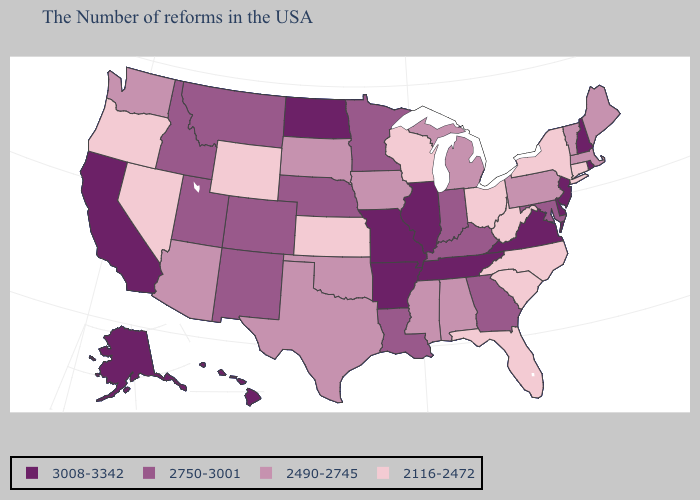Among the states that border Mississippi , does Alabama have the lowest value?
Quick response, please. Yes. Which states hav the highest value in the South?
Be succinct. Delaware, Virginia, Tennessee, Arkansas. What is the value of Connecticut?
Keep it brief. 2116-2472. Name the states that have a value in the range 2116-2472?
Keep it brief. Connecticut, New York, North Carolina, South Carolina, West Virginia, Ohio, Florida, Wisconsin, Kansas, Wyoming, Nevada, Oregon. Does the first symbol in the legend represent the smallest category?
Quick response, please. No. Name the states that have a value in the range 3008-3342?
Be succinct. Rhode Island, New Hampshire, New Jersey, Delaware, Virginia, Tennessee, Illinois, Missouri, Arkansas, North Dakota, California, Alaska, Hawaii. Does Maine have the highest value in the USA?
Quick response, please. No. What is the value of North Dakota?
Keep it brief. 3008-3342. Does Illinois have the highest value in the MidWest?
Short answer required. Yes. Name the states that have a value in the range 2490-2745?
Answer briefly. Maine, Massachusetts, Vermont, Pennsylvania, Michigan, Alabama, Mississippi, Iowa, Oklahoma, Texas, South Dakota, Arizona, Washington. What is the value of Washington?
Give a very brief answer. 2490-2745. Is the legend a continuous bar?
Give a very brief answer. No. Does Illinois have the highest value in the MidWest?
Write a very short answer. Yes. Does Kansas have the same value as South Dakota?
Write a very short answer. No. What is the value of Georgia?
Quick response, please. 2750-3001. 